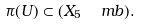<formula> <loc_0><loc_0><loc_500><loc_500>\pi ( U ) \subset ( X _ { 5 } \ \ m b ) .</formula> 